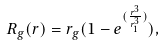Convert formula to latex. <formula><loc_0><loc_0><loc_500><loc_500>R _ { g } ( r ) = r _ { g } ( 1 - e ^ { ( \frac { r ^ { 3 } } { r _ { 1 } ^ { 3 } } ) } ) ,</formula> 